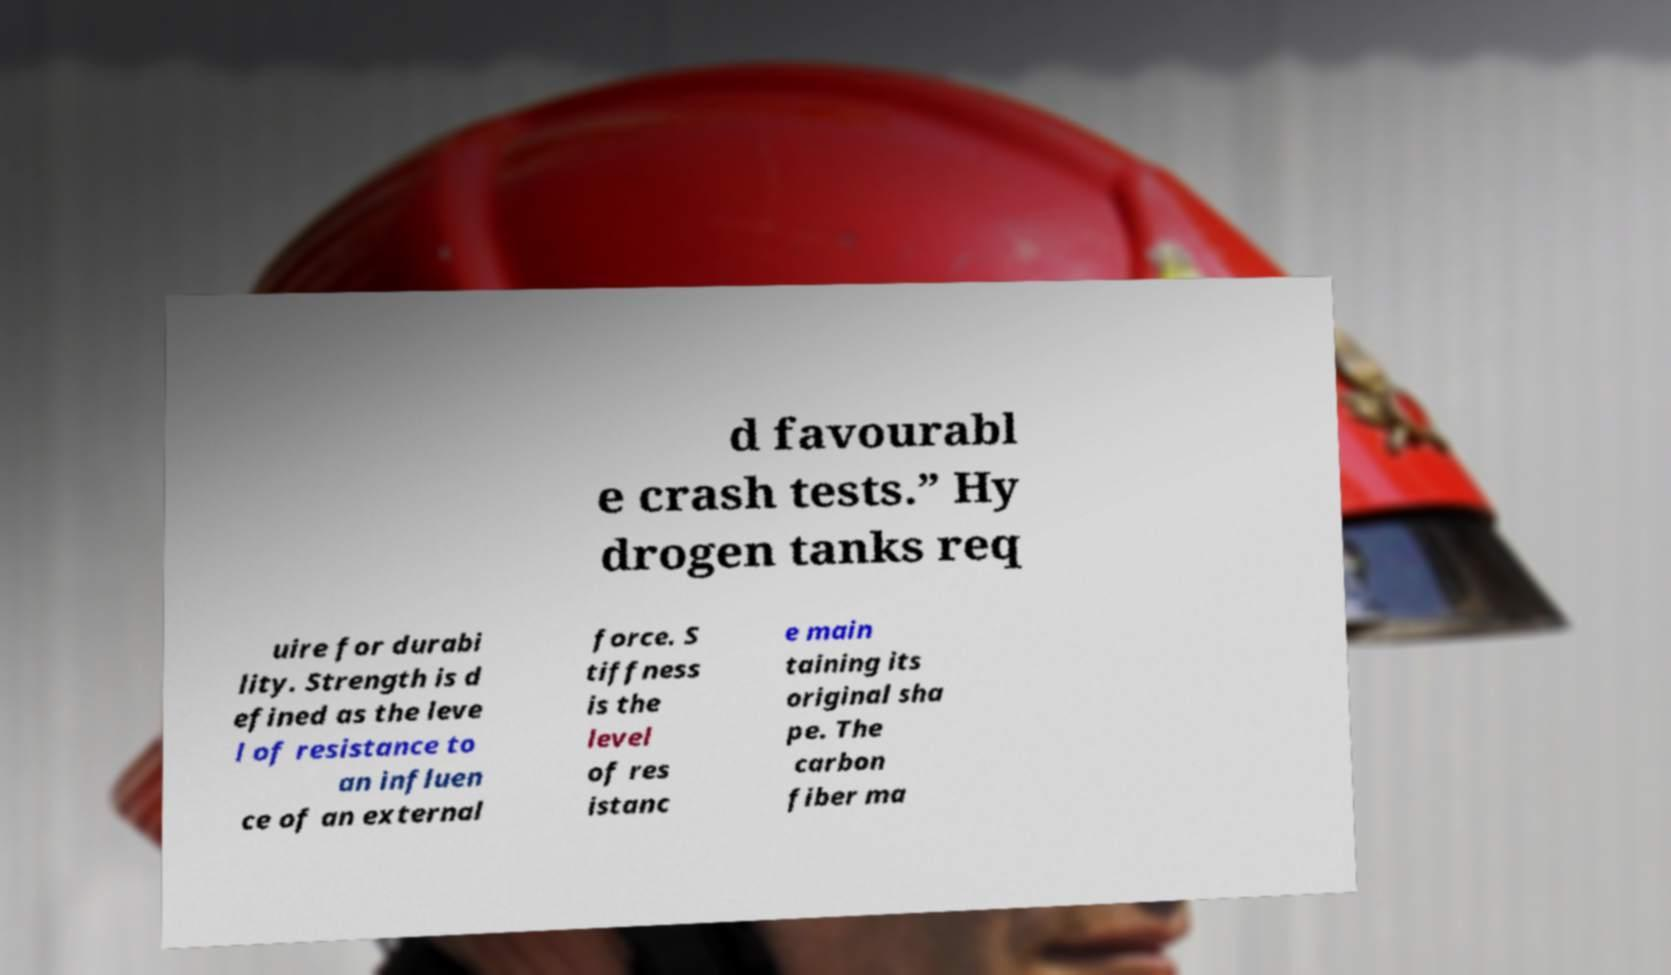Can you read and provide the text displayed in the image?This photo seems to have some interesting text. Can you extract and type it out for me? d favourabl e crash tests.” Hy drogen tanks req uire for durabi lity. Strength is d efined as the leve l of resistance to an influen ce of an external force. S tiffness is the level of res istanc e main taining its original sha pe. The carbon fiber ma 